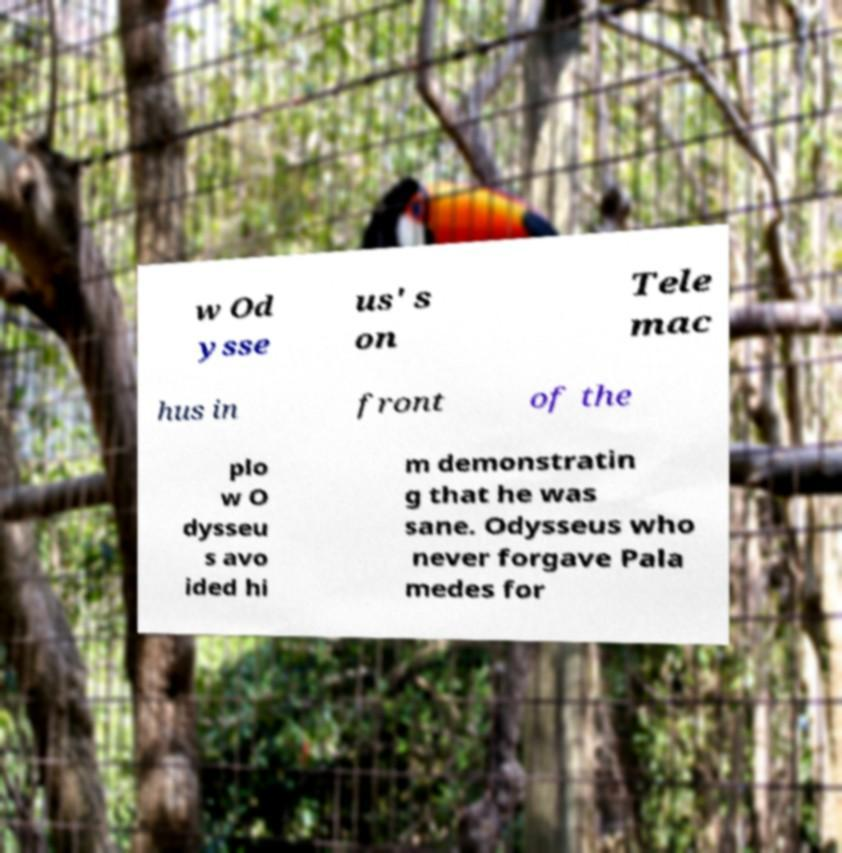Can you accurately transcribe the text from the provided image for me? w Od ysse us' s on Tele mac hus in front of the plo w O dysseu s avo ided hi m demonstratin g that he was sane. Odysseus who never forgave Pala medes for 